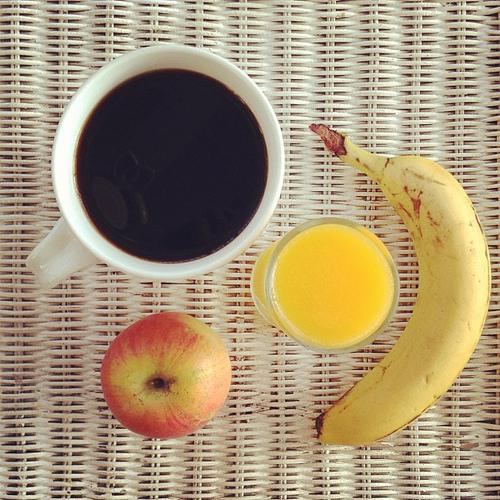Question: what color is the juice?
Choices:
A. Red.
B. Purple.
C. Orange.
D. Yellow.
Answer with the letter. Answer: C Question: what is in the cup?
Choices:
A. Tea.
B. Pop.
C. Juice.
D. Coffee.
Answer with the letter. Answer: D Question: what color is the banana?
Choices:
A. Brown.
B. Yellow.
C. Black.
D. Green.
Answer with the letter. Answer: B Question: how many bananas are there?
Choices:
A. Two.
B. Three.
C. Four.
D. One.
Answer with the letter. Answer: D 